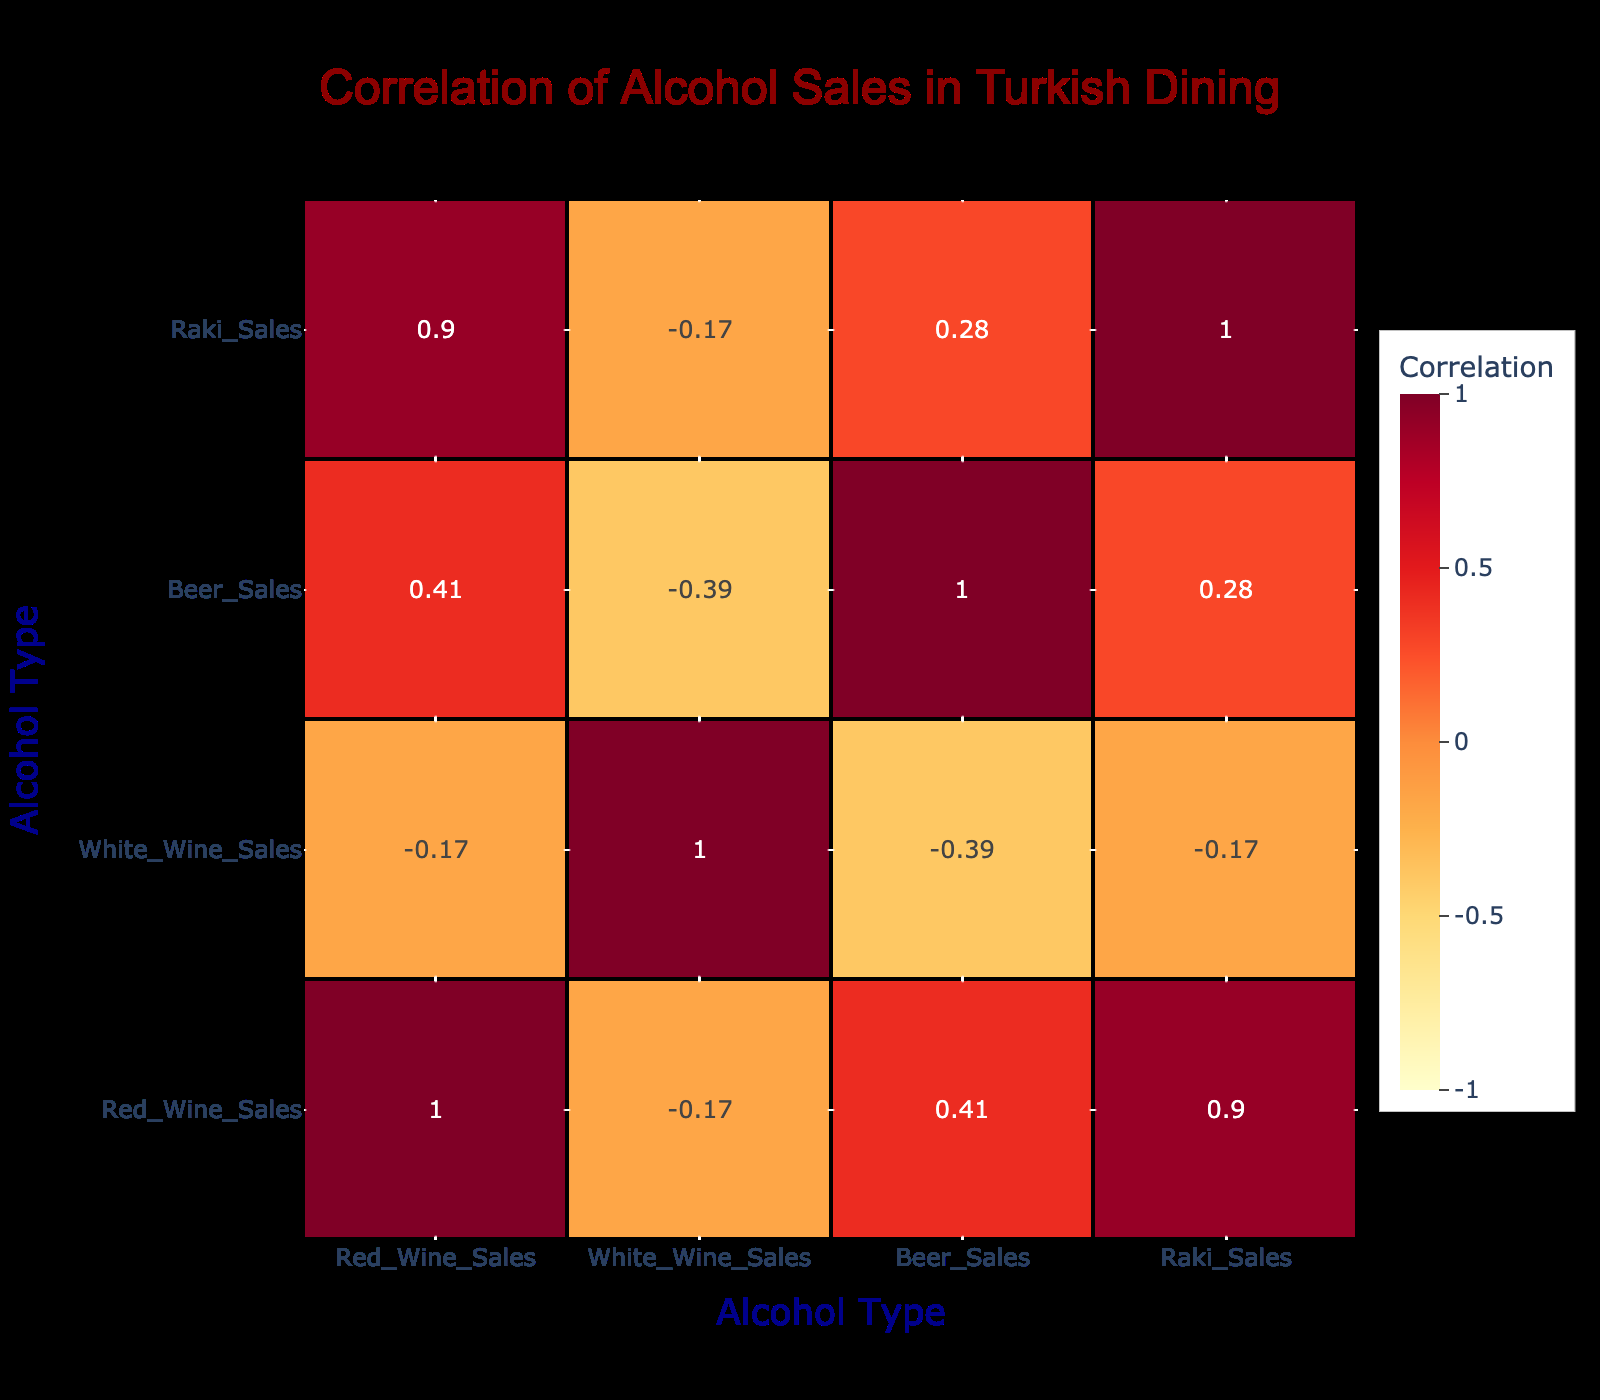What is the correlation between Red Wine Sales and Raki Sales? By looking at the correlation table, we can see the correlation value between Red Wine Sales and Raki Sales is 0.63, indicating a moderately strong positive correlation.
Answer: 0.63 Which food pairing has the highest Beer Sales? The food pairing that has the highest Beer Sales is Lahmacun, with 100 sales recorded for beer.
Answer: 100 Is there a negative correlation between White Wine Sales and Raki Sales? The correlation between White Wine Sales and Raki Sales is -0.36. This indicates a slight negative correlation, meaning as White Wine Sales increase, Raki Sales tend to decrease, which confirms the statement.
Answer: Yes What is the average Red Wine Sales for all food pairings? To find the average, sum the Red Wine Sales (150 + 100 + 90 + 80 + 20 + 30 + 60 + 70 + 40 + 110) = 750, and there are 10 pairs, so the average is 750/10 = 75.
Answer: 75 Which food pairing has the lowest White Wine Sales? The food pairing with the lowest White Wine Sales is Köfte, with only 15 sales recorded for white wine.
Answer: 15 What is the total Raki Sales for Meze and Manti? To find the total Raki Sales for Meze and Manti, we need to add their individual sales: Meze has 100 sales and Manti has 80 sales. Thus, 100 + 80 = 180.
Answer: 180 Is the correlation between Beer Sales and Seafood Sales positive? The correlation between Beer Sales and Seafood is 0.33, indicating a positive correlation, meaning they generally increase together.
Answer: Yes What is the difference between the highest and lowest Red Wine Sales in the food pairings? The highest Red Wine Sales is 150 (Kebap) and the lowest is 20 (Baklava). The difference is 150 - 20 = 130.
Answer: 130 